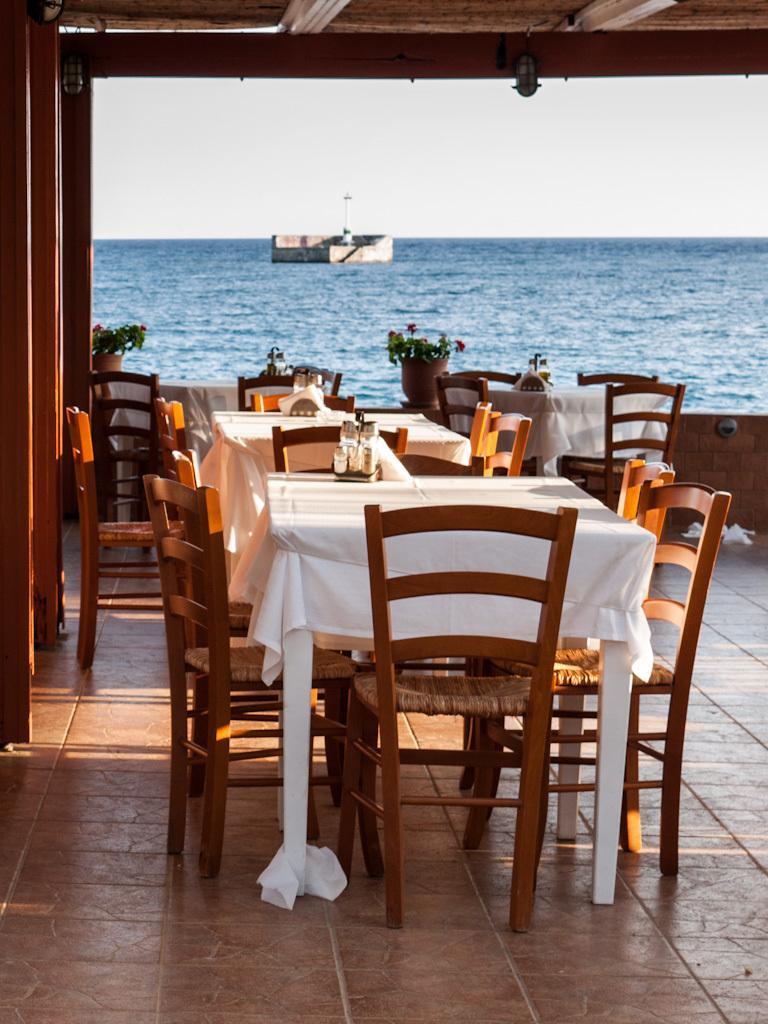In one or two sentences, can you explain what this image depicts? In this image I can see few chairs around the table which are white in color and I can see the chairs are brown in color. On the table I can see few objects. In the background I can see few flower pots with plants in it, the water and the sky. 